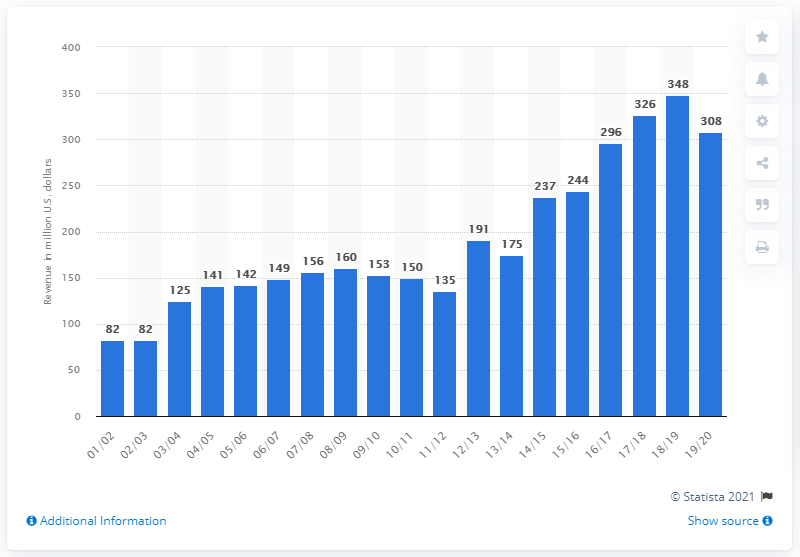Specify some key components in this picture. The estimated revenue of the Houston Rockets for the 2019/2020 season was approximately 308 million US dollars. 